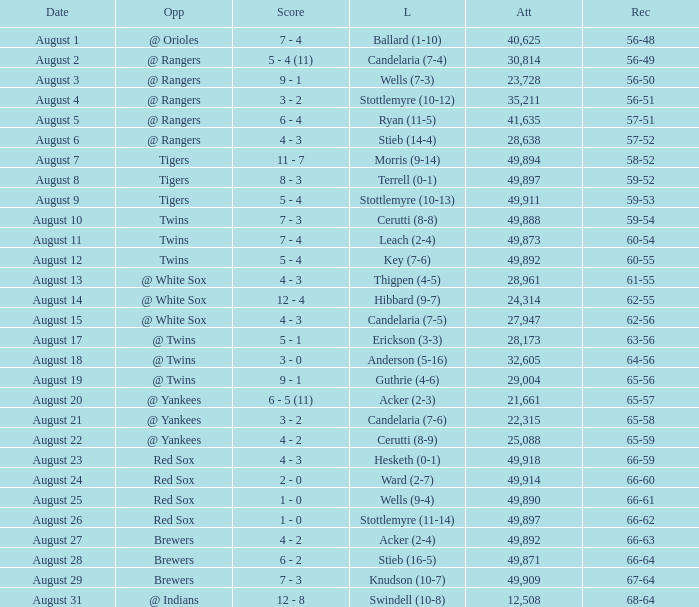What was the Attendance high on August 28? 49871.0. 